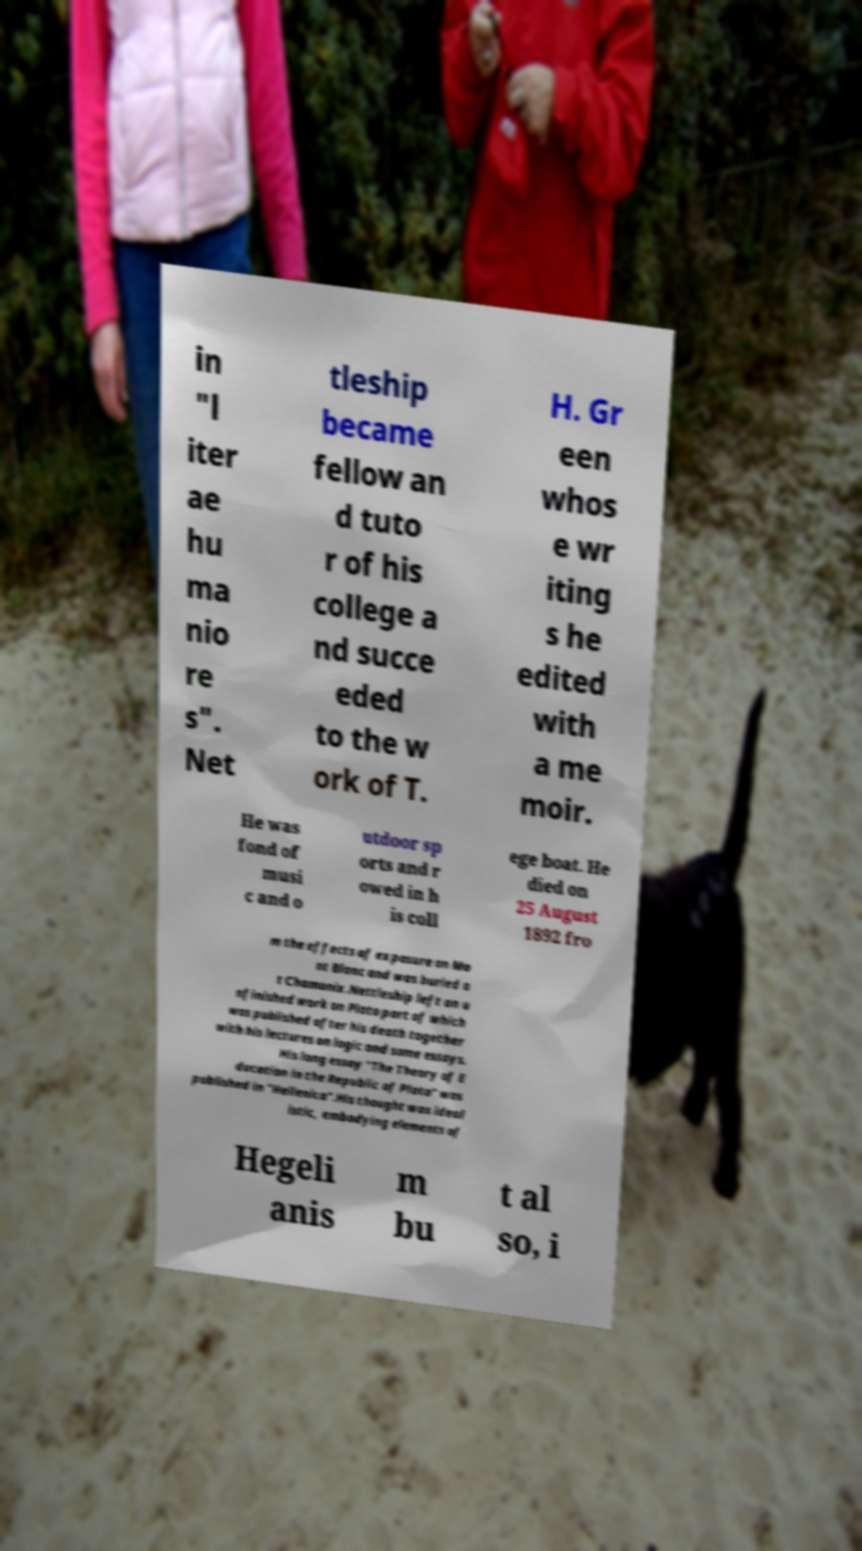There's text embedded in this image that I need extracted. Can you transcribe it verbatim? in "l iter ae hu ma nio re s". Net tleship became fellow an d tuto r of his college a nd succe eded to the w ork of T. H. Gr een whos e wr iting s he edited with a me moir. He was fond of musi c and o utdoor sp orts and r owed in h is coll ege boat. He died on 25 August 1892 fro m the effects of exposure on Mo nt Blanc and was buried a t Chamonix.Nettleship left an u nfinished work on Plato part of which was published after his death together with his lectures on logic and some essays. His long essay "The Theory of E ducation in the Republic of Plato" was published in "Hellenica".His thought was ideal istic, embodying elements of Hegeli anis m bu t al so, i 